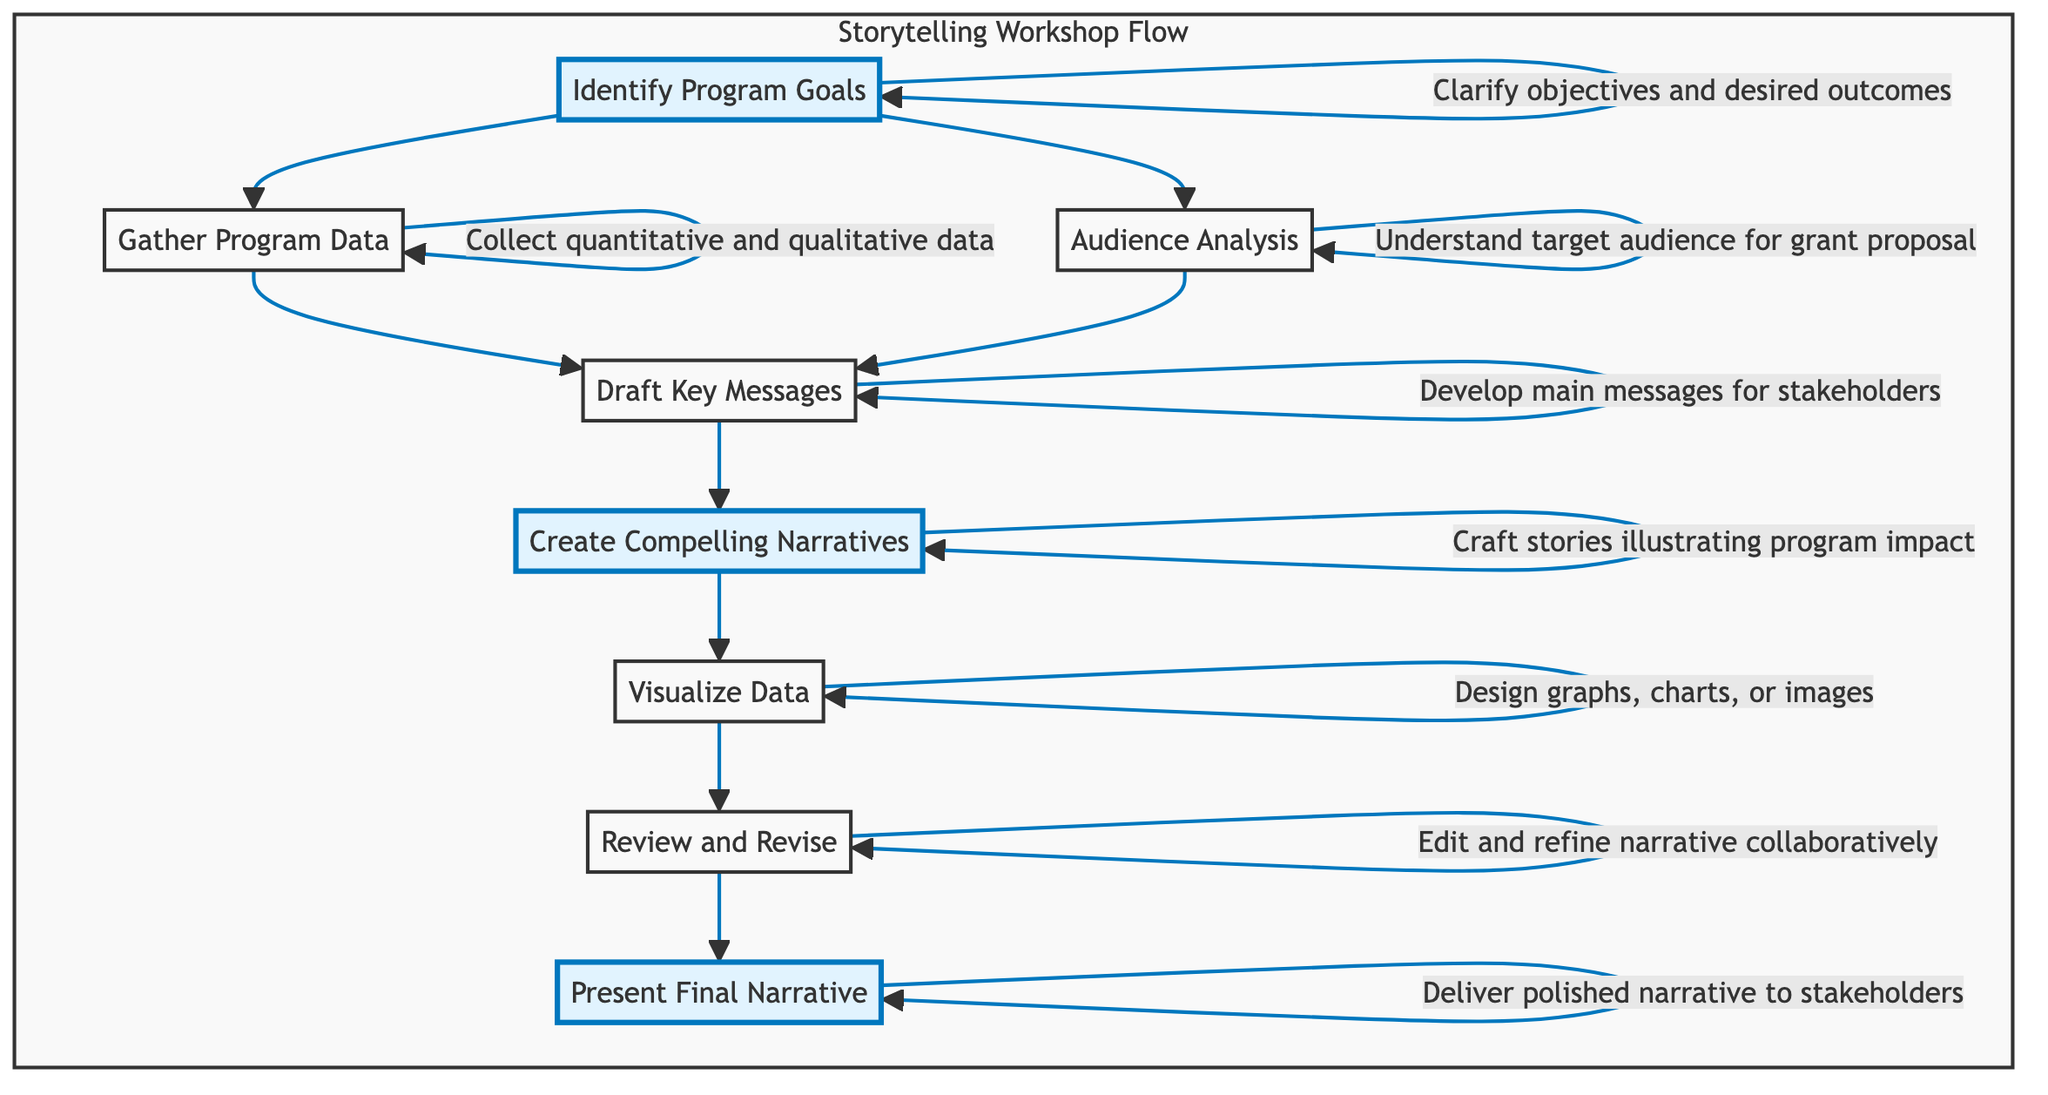What is the first step in the storytelling workshop flow? The first step listed in the flow is "Identify Program Goals." It is the top most element and serves as the starting point for the process.
Answer: Identify Program Goals How many nodes are present in the diagram? The diagram contains eight distinct elements that represent steps in the process. Each box in the flowchart counts as a node, and there are eight in total.
Answer: 8 What follows "Gather Program Data" in the flow? "Draft Key Messages" is the next step that follows "Gather Program Data." The arrows indicate the flow from one step to the next.
Answer: Draft Key Messages Which steps are emphasized in the diagram? The steps that are highlighted in the diagram are "Identify Program Goals," "Create Compelling Narratives," and "Present Final Narrative." These three steps use a different color scheme compared to the others.
Answer: Identify Program Goals, Create Compelling Narratives, Present Final Narrative What does "Visualize Data" lead to in the workflow? "Visualize Data" is followed by "Review and Revise." The arrows in the diagram show a direct transition from visualizing data to reviewing and revising the narrative.
Answer: Review and Revise How many paths lead from "Audience Analysis"? There are two paths leading from "Audience Analysis": one path directs to "Draft Key Messages," and the other does not, thus indicating a single outgoing path to the following element.
Answer: 1 What is the relationship between "Draft Key Messages" and "Create Compelling Narratives"? "Draft Key Messages" flows directly into "Create Compelling Narratives," indicating that drafting key messages is a prerequisite for creating compelling narratives.
Answer: Direct flow Which step comes after "Review and Revise"? The step that follows "Review and Revise" in the workflow is "Present Final Narrative." This sequence highlights the final step of delivering the narrative.
Answer: Present Final Narrative 